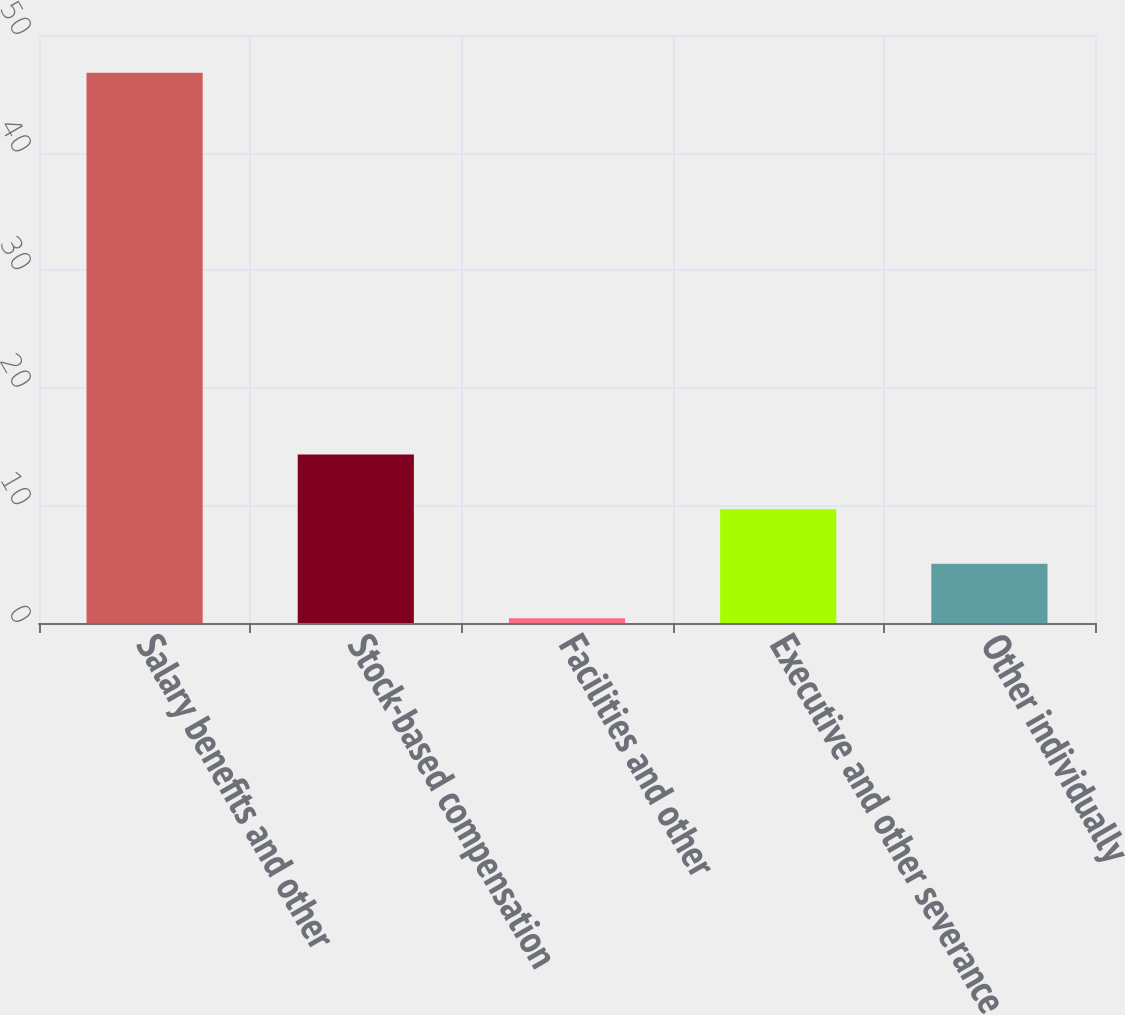Convert chart to OTSL. <chart><loc_0><loc_0><loc_500><loc_500><bar_chart><fcel>Salary benefits and other<fcel>Stock-based compensation<fcel>Facilities and other<fcel>Executive and other severance<fcel>Other individually<nl><fcel>46.8<fcel>14.32<fcel>0.4<fcel>9.68<fcel>5.04<nl></chart> 